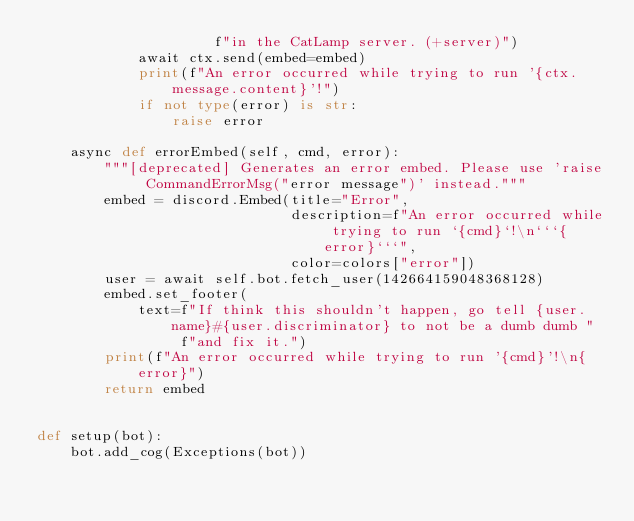<code> <loc_0><loc_0><loc_500><loc_500><_Python_>                     f"in the CatLamp server. (+server)")
            await ctx.send(embed=embed)
            print(f"An error occurred while trying to run '{ctx.message.content}'!")
            if not type(error) is str:
                raise error

    async def errorEmbed(self, cmd, error):
        """[deprecated] Generates an error embed. Please use 'raise CommandErrorMsg("error message")' instead."""
        embed = discord.Embed(title="Error",
                              description=f"An error occurred while trying to run `{cmd}`!\n```{error}```",
                              color=colors["error"])
        user = await self.bot.fetch_user(142664159048368128)
        embed.set_footer(
            text=f"If think this shouldn't happen, go tell {user.name}#{user.discriminator} to not be a dumb dumb "
                 f"and fix it.")
        print(f"An error occurred while trying to run '{cmd}'!\n{error}")
        return embed


def setup(bot):
    bot.add_cog(Exceptions(bot))
</code> 